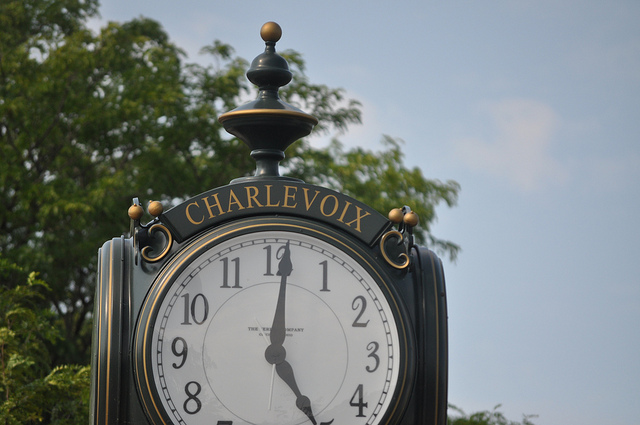<image>What design is on the clock? I am not sure what design is on the clock. It can be modern, gold paint, abstract, or classic. What design is on the clock? I am not sure what design is on the clock. It can be seen as modern, charlevoix, gold paint, fancy, abstract, gold design, classic circular design, or classic. 